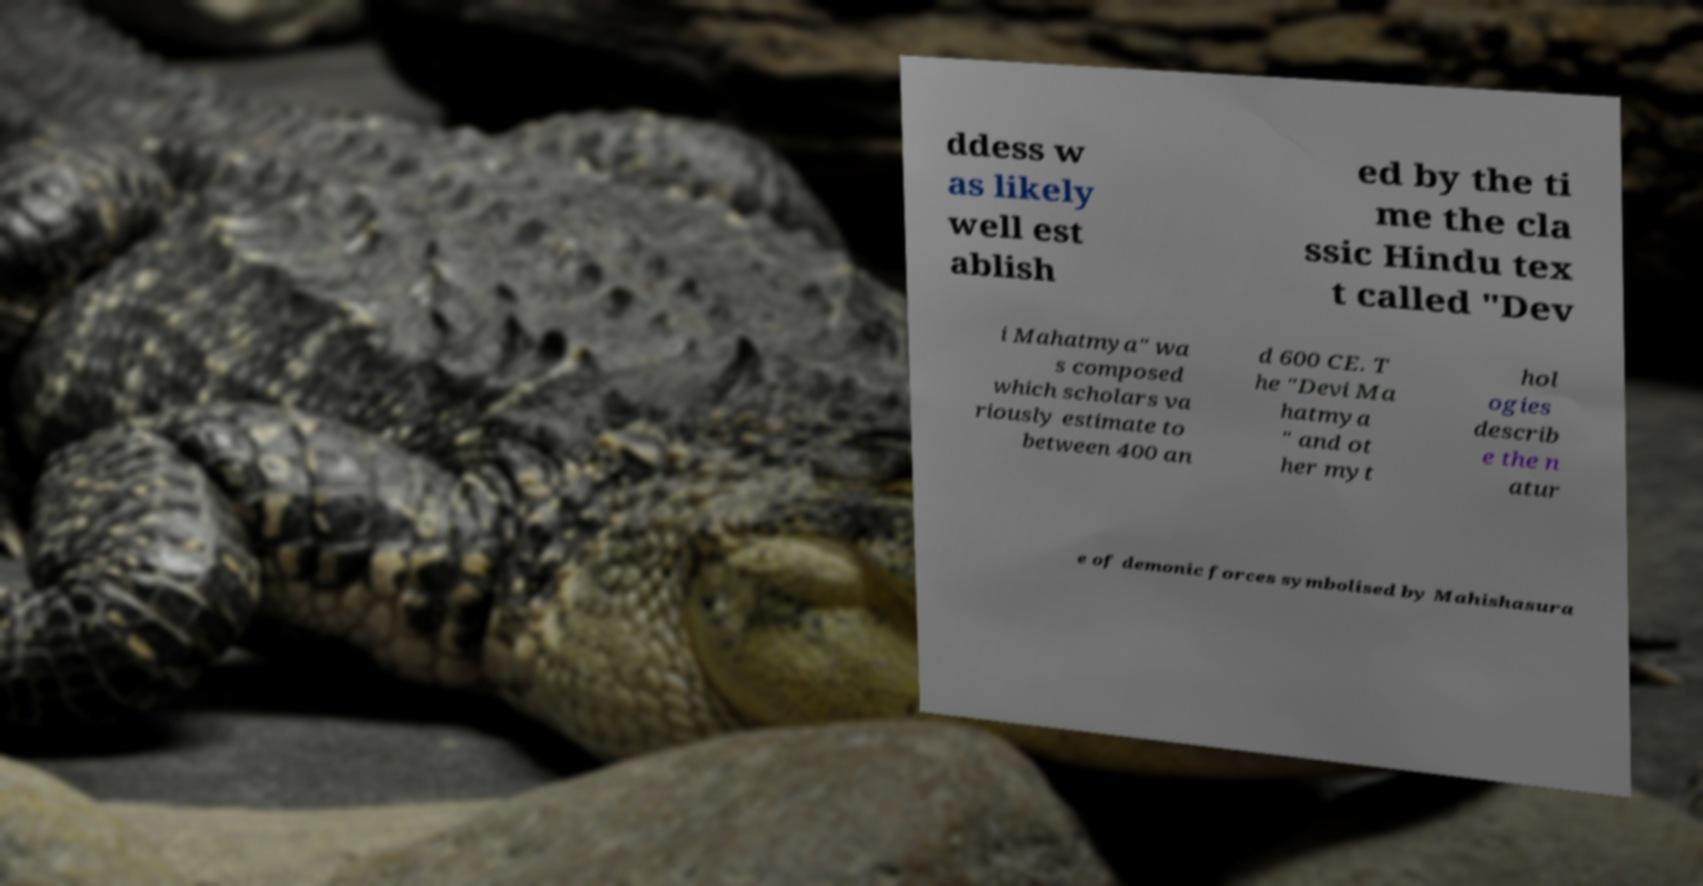Please read and relay the text visible in this image. What does it say? ddess w as likely well est ablish ed by the ti me the cla ssic Hindu tex t called "Dev i Mahatmya" wa s composed which scholars va riously estimate to between 400 an d 600 CE. T he "Devi Ma hatmya " and ot her myt hol ogies describ e the n atur e of demonic forces symbolised by Mahishasura 